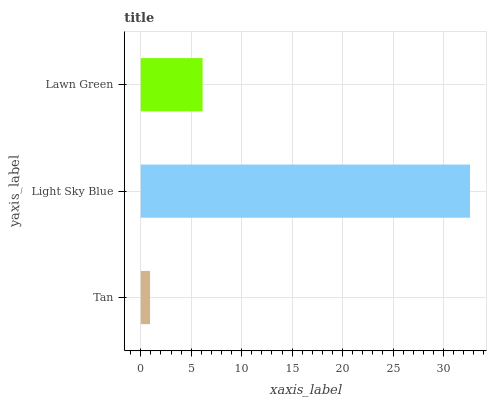Is Tan the minimum?
Answer yes or no. Yes. Is Light Sky Blue the maximum?
Answer yes or no. Yes. Is Lawn Green the minimum?
Answer yes or no. No. Is Lawn Green the maximum?
Answer yes or no. No. Is Light Sky Blue greater than Lawn Green?
Answer yes or no. Yes. Is Lawn Green less than Light Sky Blue?
Answer yes or no. Yes. Is Lawn Green greater than Light Sky Blue?
Answer yes or no. No. Is Light Sky Blue less than Lawn Green?
Answer yes or no. No. Is Lawn Green the high median?
Answer yes or no. Yes. Is Lawn Green the low median?
Answer yes or no. Yes. Is Tan the high median?
Answer yes or no. No. Is Tan the low median?
Answer yes or no. No. 